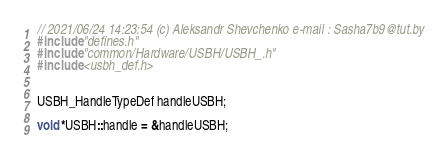<code> <loc_0><loc_0><loc_500><loc_500><_C++_>// 2021/06/24 14:23:54 (c) Aleksandr Shevchenko e-mail : Sasha7b9@tut.by
#include "defines.h"
#include "common/Hardware/USBH/USBH_.h"
#include <usbh_def.h>


USBH_HandleTypeDef handleUSBH;

void *USBH::handle = &handleUSBH;

</code> 